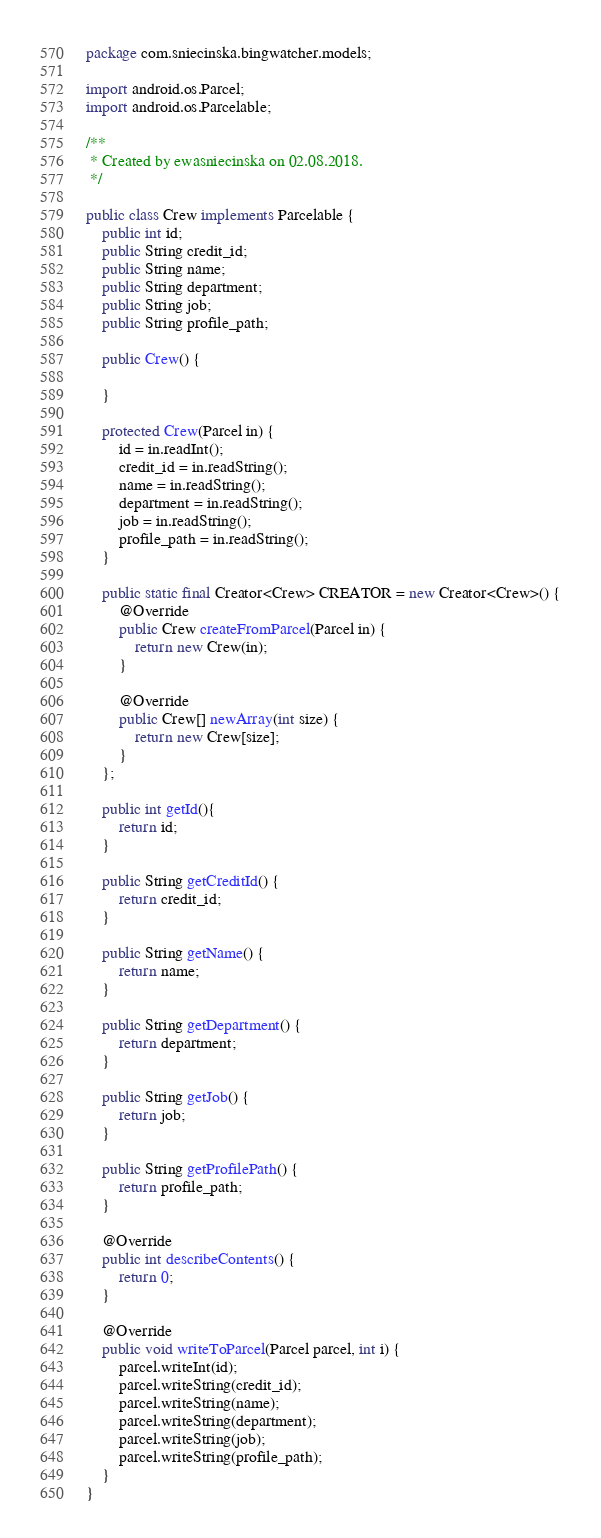Convert code to text. <code><loc_0><loc_0><loc_500><loc_500><_Java_>package com.sniecinska.bingwatcher.models;

import android.os.Parcel;
import android.os.Parcelable;

/**
 * Created by ewasniecinska on 02.08.2018.
 */

public class Crew implements Parcelable {
    public int id;
    public String credit_id;
    public String name;
    public String department;
    public String job;
    public String profile_path;

    public Crew() {

    }

    protected Crew(Parcel in) {
        id = in.readInt();
        credit_id = in.readString();
        name = in.readString();
        department = in.readString();
        job = in.readString();
        profile_path = in.readString();
    }

    public static final Creator<Crew> CREATOR = new Creator<Crew>() {
        @Override
        public Crew createFromParcel(Parcel in) {
            return new Crew(in);
        }

        @Override
        public Crew[] newArray(int size) {
            return new Crew[size];
        }
    };

    public int getId(){
        return id;
    }

    public String getCreditId() {
        return credit_id;
    }

    public String getName() {
        return name;
    }

    public String getDepartment() {
        return department;
    }

    public String getJob() {
        return job;
    }

    public String getProfilePath() {
        return profile_path;
    }

    @Override
    public int describeContents() {
        return 0;
    }

    @Override
    public void writeToParcel(Parcel parcel, int i) {
        parcel.writeInt(id);
        parcel.writeString(credit_id);
        parcel.writeString(name);
        parcel.writeString(department);
        parcel.writeString(job);
        parcel.writeString(profile_path);
    }
}
</code> 